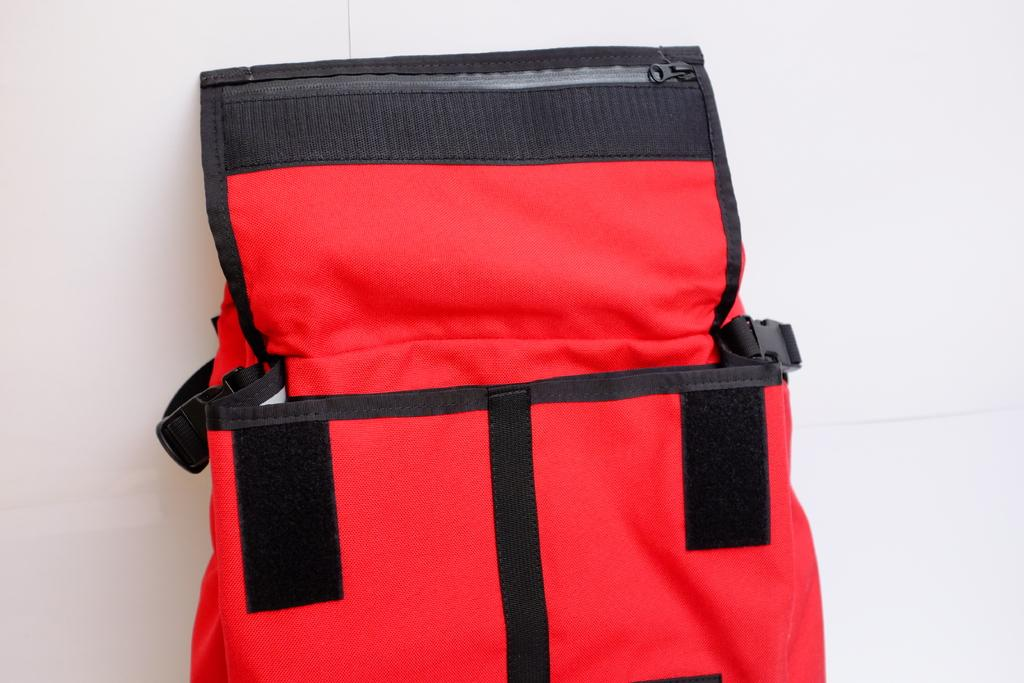What object is present in the image? There is a bag in the image. What color is the bag? The bag is red. What is the color of the background in the image? The background in the image is white. Is there a throne visible in the image? No, there is no throne present in the image. Can you see the person's feet in the image? There is no person present in the image, so their feet cannot be seen. 